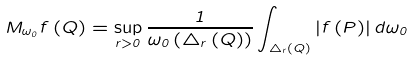<formula> <loc_0><loc_0><loc_500><loc_500>M _ { \omega _ { 0 } } f \left ( Q \right ) = \sup _ { r > 0 } \frac { 1 } { \omega _ { 0 } \left ( \triangle _ { r } \left ( Q \right ) \right ) } \int _ { \triangle _ { r } \left ( Q \right ) } \left | f \left ( P \right ) \right | d \omega _ { 0 }</formula> 